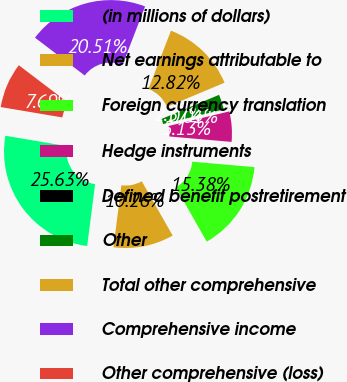Convert chart to OTSL. <chart><loc_0><loc_0><loc_500><loc_500><pie_chart><fcel>(in millions of dollars)<fcel>Net earnings attributable to<fcel>Foreign currency translation<fcel>Hedge instruments<fcel>Defined benefit postretirement<fcel>Other<fcel>Total other comprehensive<fcel>Comprehensive income<fcel>Other comprehensive (loss)<nl><fcel>25.63%<fcel>10.26%<fcel>15.38%<fcel>5.13%<fcel>0.01%<fcel>2.57%<fcel>12.82%<fcel>20.51%<fcel>7.69%<nl></chart> 